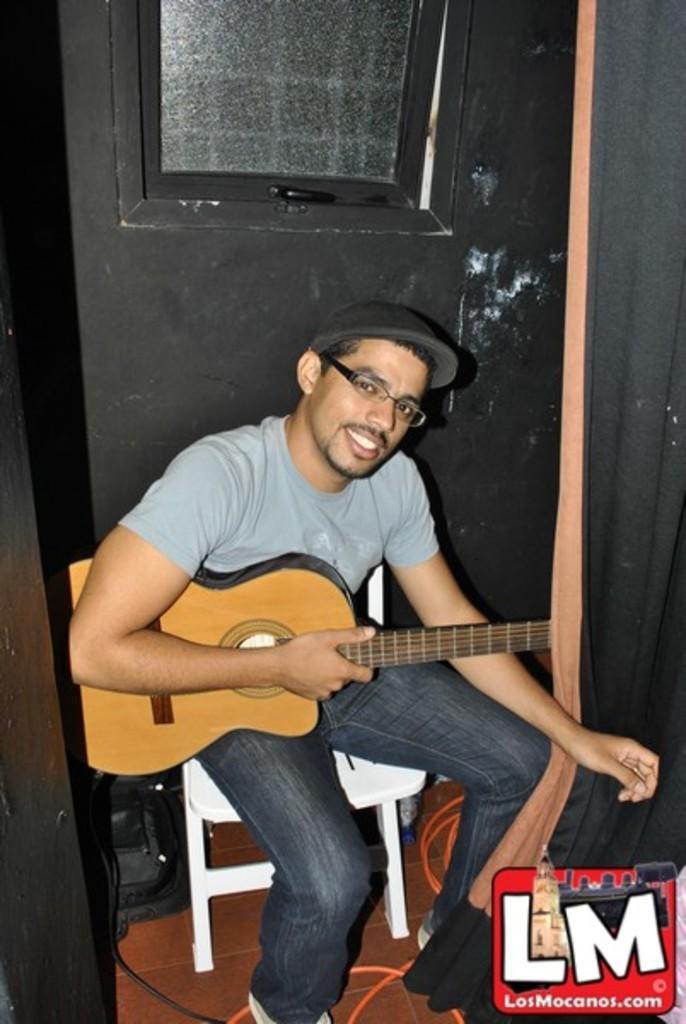How would you summarize this image in a sentence or two? The person wearing black hat is sitting on a chair and holding a guitar in his hands. 